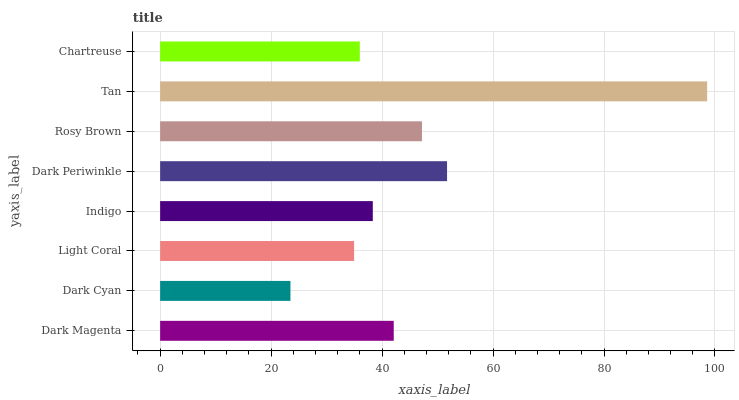Is Dark Cyan the minimum?
Answer yes or no. Yes. Is Tan the maximum?
Answer yes or no. Yes. Is Light Coral the minimum?
Answer yes or no. No. Is Light Coral the maximum?
Answer yes or no. No. Is Light Coral greater than Dark Cyan?
Answer yes or no. Yes. Is Dark Cyan less than Light Coral?
Answer yes or no. Yes. Is Dark Cyan greater than Light Coral?
Answer yes or no. No. Is Light Coral less than Dark Cyan?
Answer yes or no. No. Is Dark Magenta the high median?
Answer yes or no. Yes. Is Indigo the low median?
Answer yes or no. Yes. Is Indigo the high median?
Answer yes or no. No. Is Rosy Brown the low median?
Answer yes or no. No. 